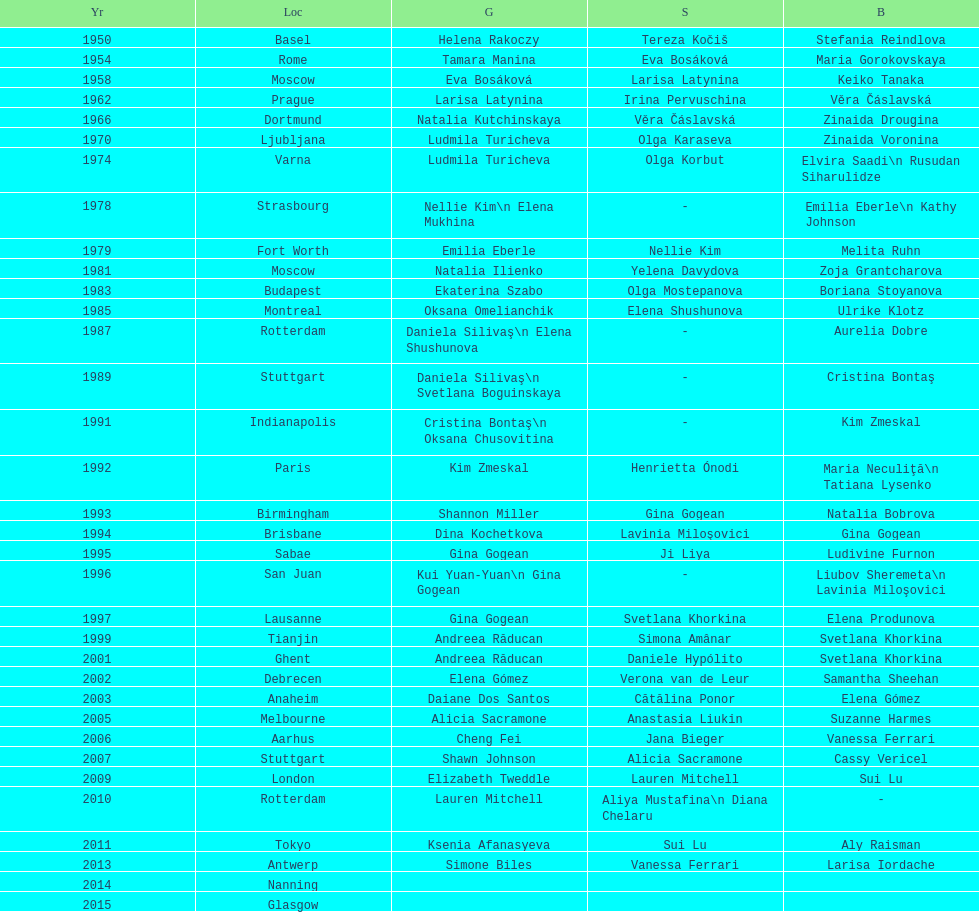How many times was the location in the united states? 3. 